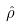<formula> <loc_0><loc_0><loc_500><loc_500>\hat { \rho }</formula> 